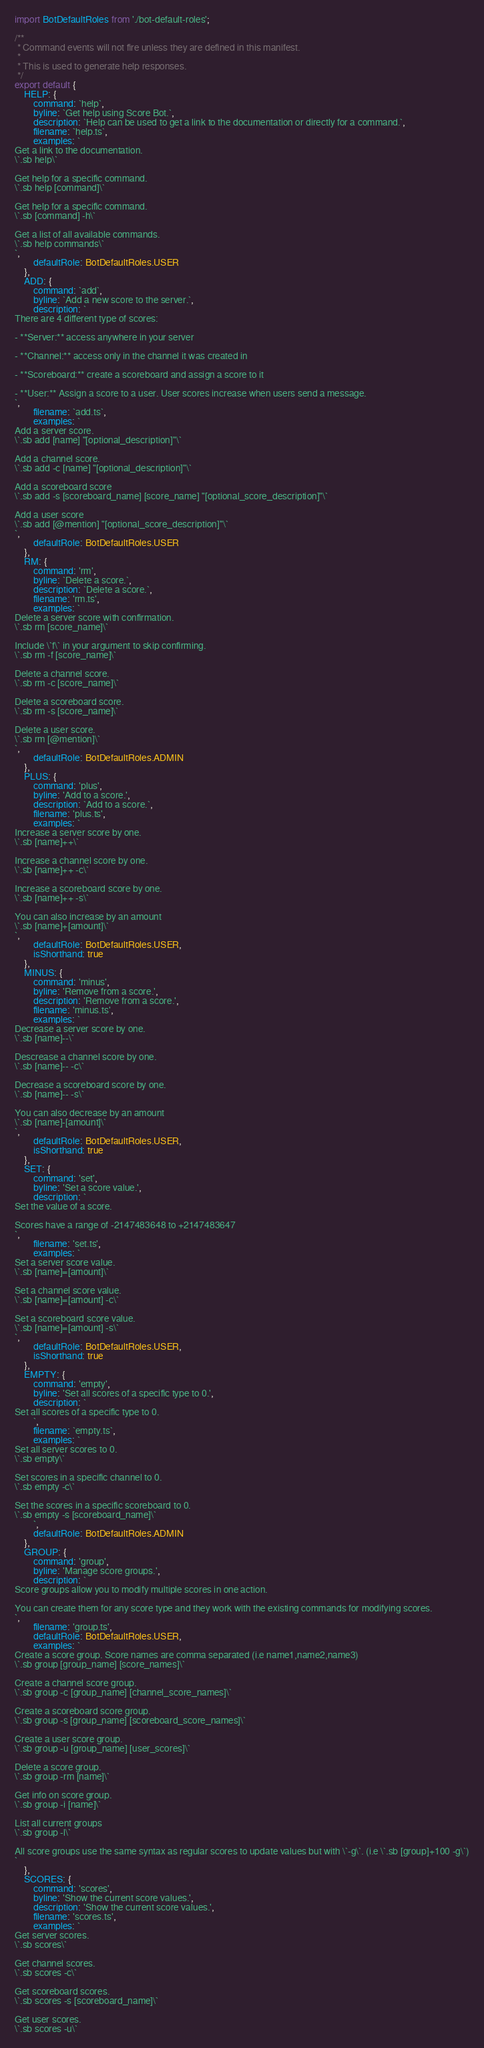Convert code to text. <code><loc_0><loc_0><loc_500><loc_500><_TypeScript_>import BotDefaultRoles from './bot-default-roles';

/**
 * Command events will not fire unless they are defined in this manifest.
 * 
 * This is used to generate help responses.
 */
export default {
    HELP: {
        command: `help`,
        byline: `Get help using Score Bot.`,
        description: `Help can be used to get a link to the documentation or directly for a command.`,
        filename: `help.ts`,
        examples: `
Get a link to the documentation.
\`.sb help\`

Get help for a specific command.
\`.sb help [command]\`

Get help for a specific command.
\`.sb [command] -h\`

Get a list of all available commands.
\`.sb help commands\`
`,
        defaultRole: BotDefaultRoles.USER
    },
    ADD: {
        command: `add`,
        byline: `Add a new score to the server.`,
        description: `
There are 4 different type of scores:

- **Server:** access anywhere in your server

- **Channel:** access only in the channel it was created in

- **Scoreboard:** create a scoreboard and assign a score to it

- **User:** Assign a score to a user. User scores increase when users send a message.        
`,
        filename: `add.ts`,
        examples: `
Add a server score.
\`.sb add [name] "[optional_description]"\`

Add a channel score.
\`.sb add -c [name] "[optional_description]"\`

Add a scoreboard score
\`.sb add -s [scoreboard_name] [score_name] "[optional_score_description]"\`

Add a user score
\`.sb add [@mention] "[optional_score_description]"\`
`,
        defaultRole: BotDefaultRoles.USER
    },
    RM: {
        command: 'rm',
        byline: `Delete a score.`,
        description: `Delete a score.`,
        filename: 'rm.ts',
        examples: `
Delete a server score with confirmation.
\`.sb rm [score_name]\`

Include \`f\` in your argument to skip confirming.
\`.sb rm -f [score_name]\`

Delete a channel score.
\`.sb rm -c [score_name]\`

Delete a scoreboard score.
\`.sb rm -s [score_name]\`

Delete a user score.
\`.sb rm [@mention]\`
`,
        defaultRole: BotDefaultRoles.ADMIN
    },
    PLUS: {
        command: 'plus',
        byline: 'Add to a score.',
        description: `Add to a score.`,
        filename: 'plus.ts',
        examples: `
Increase a server score by one.
\`.sb [name]++\`

Increase a channel score by one.
\`.sb [name]++ -c\`

Increase a scoreboard score by one.
\`.sb [name]++ -s\`

You can also increase by an amount
\`.sb [name]+[amount]\`
`,
        defaultRole: BotDefaultRoles.USER,
        isShorthand: true
    },
    MINUS: {
        command: 'minus',
        byline: 'Remove from a score.',
        description: 'Remove from a score.',
        filename: 'minus.ts',
        examples: `
Decrease a server score by one.
\`.sb [name]--\`

Descrease a channel score by one.
\`.sb [name]-- -c\`

Decrease a scoreboard score by one.
\`.sb [name]-- -s\`

You can also decrease by an amount
\`.sb [name]-[amount]\`
`,
        defaultRole: BotDefaultRoles.USER,
        isShorthand: true
    },
    SET: {
        command: 'set',
        byline: 'Set a score value.',
        description: `
Set the value of a score. 

Scores have a range of -2147483648 to +2147483647
`,
        filename: 'set.ts',
        examples: `
Set a server score value.
\`.sb [name]=[amount]\`   

Set a channel score value.
\`.sb [name]=[amount] -c\`

Set a scoreboard score value.
\`.sb [name]=[amount] -s\` 
`,
        defaultRole: BotDefaultRoles.USER,
        isShorthand: true
    },
    EMPTY: {
        command: 'empty',
        byline: 'Set all scores of a specific type to 0.',
        description: `
Set all scores of a specific type to 0.
        `,
        filename: `empty.ts`,
        examples: `
Set all server scores to 0.
\`.sb empty\`

Set scores in a specific channel to 0.
\`.sb empty -c\`

Set the scores in a specific scoreboard to 0.
\`.sb empty -s [scoreboard_name]\`
        `,
        defaultRole: BotDefaultRoles.ADMIN
    },
    GROUP: {
        command: 'group',
        byline: 'Manage score groups.',
        description: `
Score groups allow you to modify multiple scores in one action. 

You can create them for any score type and they work with the existing commands for modifying scores.
`,
        filename: 'group.ts',
        defaultRole: BotDefaultRoles.USER,
        examples: `
Create a score group. Score names are comma separated (i.e name1,name2,name3)
\`.sb group [group_name] [score_names]\`

Create a channel score group.
\`.sb group -c [group_name] [channel_score_names]\`

Create a scoreboard score group.
\`.sb group -s [group_name] [scoreboard_score_names]\`

Create a user score group.
\`.sb group -u [group_name] [user_scores]\`

Delete a score group.
\`.sb group -rm [name]\`

Get info on score group.
\`.sb group -i [name]\`

List all current groups
\`.sb group -l\`

All score groups use the same syntax as regular scores to update values but with \`-g\`. (i.e \`.sb [group]+100 -g\`)
`
    },
    SCORES: {
        command: 'scores',
        byline: 'Show the current score values.',
        description: 'Show the current score values.',
        filename: 'scores.ts',
        examples: `
Get server scores.
\`.sb scores\`

Get channel scores.
\`.sb scores -c\`

Get scoreboard scores.
\`.sb scores -s [scoreboard_name]\`

Get user scores.
\`.sb scores -u\`
</code> 